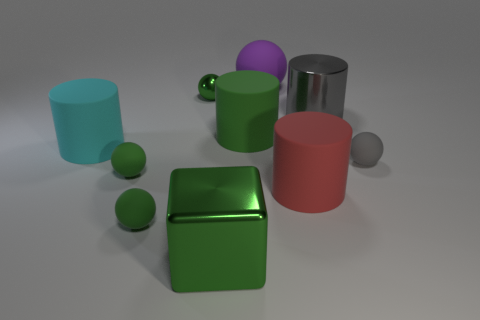Subtract all small green rubber spheres. How many spheres are left? 3 Subtract 1 blocks. How many blocks are left? 0 Subtract all purple spheres. How many spheres are left? 4 Subtract all purple cylinders. Subtract all purple blocks. How many cylinders are left? 4 Subtract all brown balls. How many cyan cylinders are left? 1 Subtract all purple spheres. Subtract all gray balls. How many objects are left? 8 Add 9 big cyan cylinders. How many big cyan cylinders are left? 10 Add 5 cyan cylinders. How many cyan cylinders exist? 6 Subtract 0 brown balls. How many objects are left? 10 Subtract all cylinders. How many objects are left? 6 